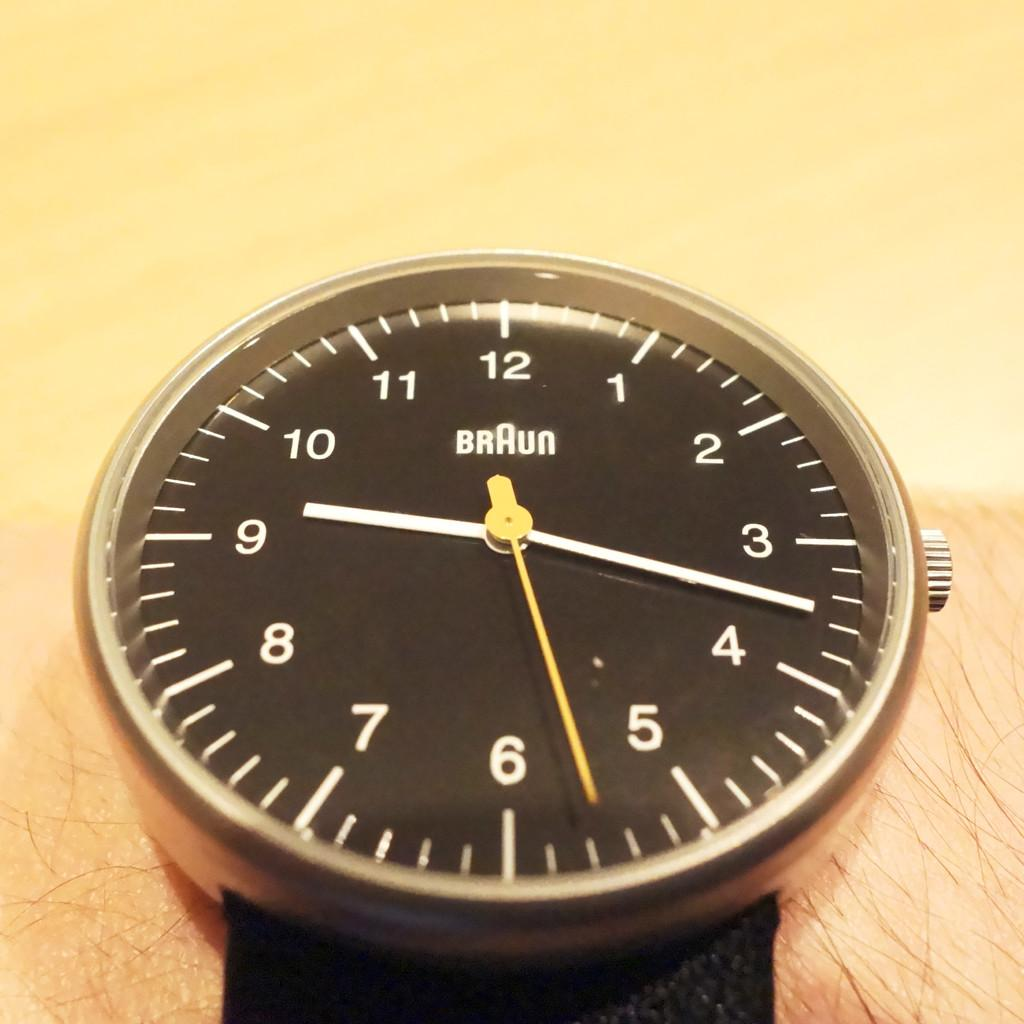<image>
Present a compact description of the photo's key features. a braun watch is black with a black band\ 